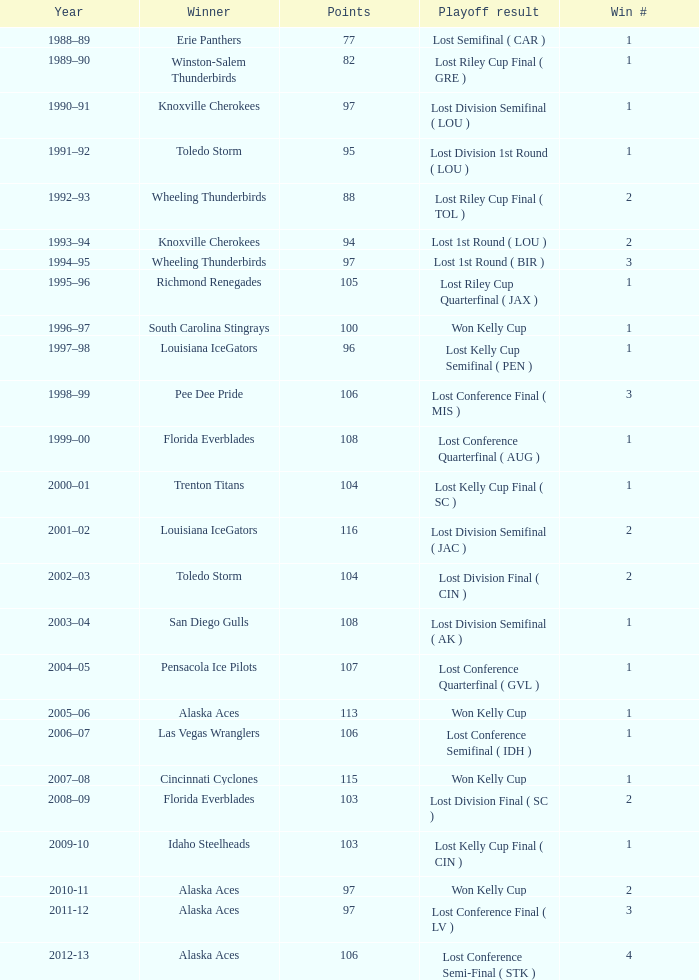Would you be able to parse every entry in this table? {'header': ['Year', 'Winner', 'Points', 'Playoff result', 'Win #'], 'rows': [['1988–89', 'Erie Panthers', '77', 'Lost Semifinal ( CAR )', '1'], ['1989–90', 'Winston-Salem Thunderbirds', '82', 'Lost Riley Cup Final ( GRE )', '1'], ['1990–91', 'Knoxville Cherokees', '97', 'Lost Division Semifinal ( LOU )', '1'], ['1991–92', 'Toledo Storm', '95', 'Lost Division 1st Round ( LOU )', '1'], ['1992–93', 'Wheeling Thunderbirds', '88', 'Lost Riley Cup Final ( TOL )', '2'], ['1993–94', 'Knoxville Cherokees', '94', 'Lost 1st Round ( LOU )', '2'], ['1994–95', 'Wheeling Thunderbirds', '97', 'Lost 1st Round ( BIR )', '3'], ['1995–96', 'Richmond Renegades', '105', 'Lost Riley Cup Quarterfinal ( JAX )', '1'], ['1996–97', 'South Carolina Stingrays', '100', 'Won Kelly Cup', '1'], ['1997–98', 'Louisiana IceGators', '96', 'Lost Kelly Cup Semifinal ( PEN )', '1'], ['1998–99', 'Pee Dee Pride', '106', 'Lost Conference Final ( MIS )', '3'], ['1999–00', 'Florida Everblades', '108', 'Lost Conference Quarterfinal ( AUG )', '1'], ['2000–01', 'Trenton Titans', '104', 'Lost Kelly Cup Final ( SC )', '1'], ['2001–02', 'Louisiana IceGators', '116', 'Lost Division Semifinal ( JAC )', '2'], ['2002–03', 'Toledo Storm', '104', 'Lost Division Final ( CIN )', '2'], ['2003–04', 'San Diego Gulls', '108', 'Lost Division Semifinal ( AK )', '1'], ['2004–05', 'Pensacola Ice Pilots', '107', 'Lost Conference Quarterfinal ( GVL )', '1'], ['2005–06', 'Alaska Aces', '113', 'Won Kelly Cup', '1'], ['2006–07', 'Las Vegas Wranglers', '106', 'Lost Conference Semifinal ( IDH )', '1'], ['2007–08', 'Cincinnati Cyclones', '115', 'Won Kelly Cup', '1'], ['2008–09', 'Florida Everblades', '103', 'Lost Division Final ( SC )', '2'], ['2009-10', 'Idaho Steelheads', '103', 'Lost Kelly Cup Final ( CIN )', '1'], ['2010-11', 'Alaska Aces', '97', 'Won Kelly Cup', '2'], ['2011-12', 'Alaska Aces', '97', 'Lost Conference Final ( LV )', '3'], ['2012-13', 'Alaska Aces', '106', 'Lost Conference Semi-Final ( STK )', '4']]} What is the highest Win #, when Winner is "Knoxville Cherokees", when Playoff Result is "Lost 1st Round ( LOU )", and when Points is less than 94? None. 